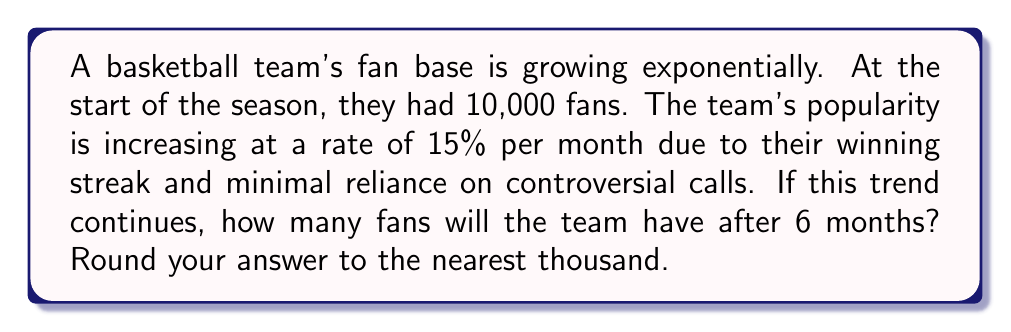Can you solve this math problem? Let's approach this step-by-step using an exponential growth model:

1) The general form of an exponential growth model is:
   $$A = P(1 + r)^t$$
   where:
   $A$ = final amount
   $P$ = initial amount
   $r$ = growth rate (as a decimal)
   $t$ = time period

2) In this problem:
   $P = 10,000$ (initial fan base)
   $r = 0.15$ (15% growth rate per month)
   $t = 6$ (months)

3) Plugging these values into our equation:
   $$A = 10,000(1 + 0.15)^6$$

4) Simplify inside the parentheses:
   $$A = 10,000(1.15)^6$$

5) Calculate $(1.15)^6$:
   $$A = 10,000 * 2.3131275$$

6) Multiply:
   $$A = 23,131.275$$

7) Rounding to the nearest thousand:
   $$A ≈ 23,000$$
Answer: 23,000 fans 